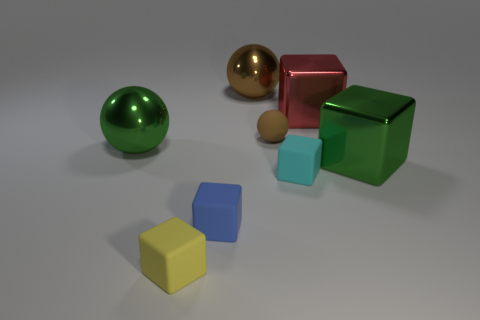How many brown things are either tiny rubber balls or small rubber cubes?
Your response must be concise. 1. What is the tiny thing behind the cyan object made of?
Your response must be concise. Rubber. Does the large sphere that is on the left side of the blue cube have the same material as the tiny blue object?
Your answer should be compact. No. What is the shape of the yellow thing?
Provide a succinct answer. Cube. There is a big shiny thing in front of the green thing that is on the left side of the small brown ball; how many tiny blue matte cubes are on the right side of it?
Give a very brief answer. 0. There is a brown object that is the same size as the red metallic thing; what is its material?
Make the answer very short. Metal. Do the matte object that is behind the green shiny block and the big metallic sphere behind the small brown object have the same color?
Ensure brevity in your answer.  Yes. Is there another matte object that has the same shape as the tiny yellow matte thing?
Provide a succinct answer. Yes. There is a cyan rubber object that is the same size as the brown matte ball; what shape is it?
Ensure brevity in your answer.  Cube. What number of metallic things have the same color as the tiny matte ball?
Make the answer very short. 1. 